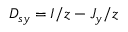Convert formula to latex. <formula><loc_0><loc_0><loc_500><loc_500>D _ { s y } = I / z - J _ { y } / z</formula> 